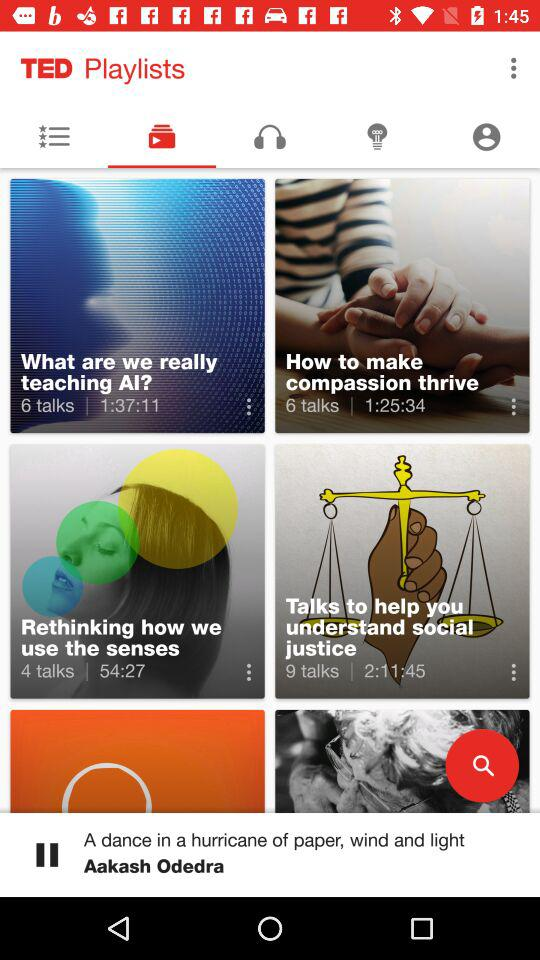How many more talks are about social justice than compassion?
Answer the question using a single word or phrase. 3 